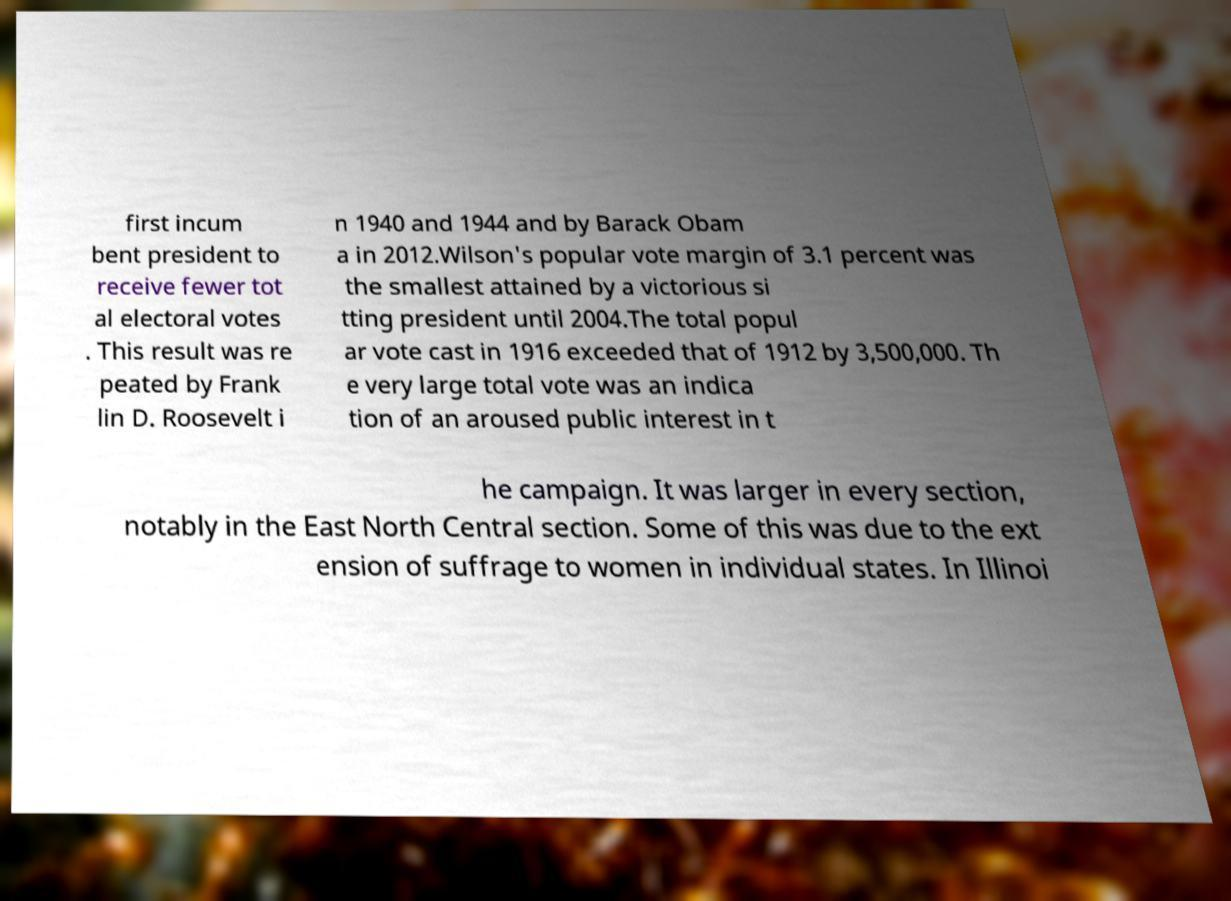There's text embedded in this image that I need extracted. Can you transcribe it verbatim? first incum bent president to receive fewer tot al electoral votes . This result was re peated by Frank lin D. Roosevelt i n 1940 and 1944 and by Barack Obam a in 2012.Wilson's popular vote margin of 3.1 percent was the smallest attained by a victorious si tting president until 2004.The total popul ar vote cast in 1916 exceeded that of 1912 by 3,500,000. Th e very large total vote was an indica tion of an aroused public interest in t he campaign. It was larger in every section, notably in the East North Central section. Some of this was due to the ext ension of suffrage to women in individual states. In Illinoi 